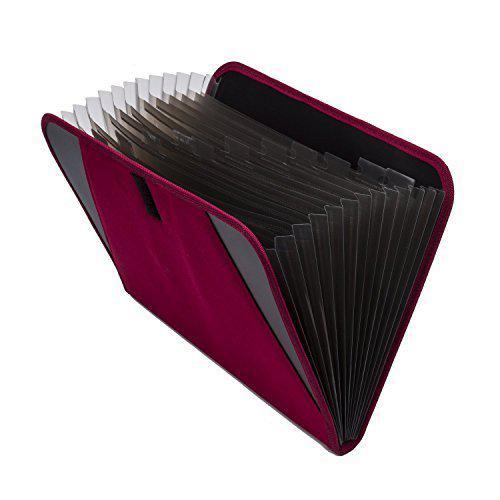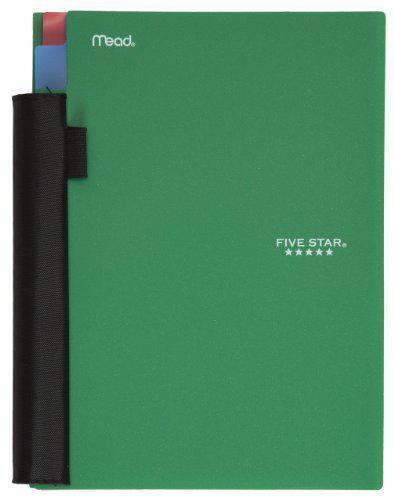The first image is the image on the left, the second image is the image on the right. Considering the images on both sides, is "The left image shows only one binder, which is purplish in color." valid? Answer yes or no. Yes. The first image is the image on the left, the second image is the image on the right. Considering the images on both sides, is "One zipper binder is unzipped and open so that at least one set of three notebook rings and multiple interior pockets are visible." valid? Answer yes or no. No. 